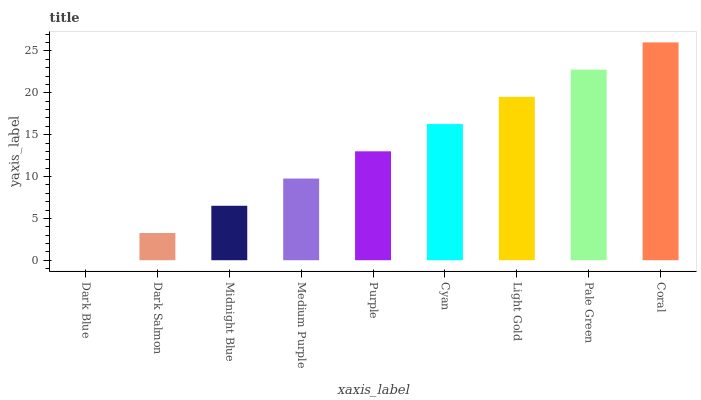Is Dark Blue the minimum?
Answer yes or no. Yes. Is Coral the maximum?
Answer yes or no. Yes. Is Dark Salmon the minimum?
Answer yes or no. No. Is Dark Salmon the maximum?
Answer yes or no. No. Is Dark Salmon greater than Dark Blue?
Answer yes or no. Yes. Is Dark Blue less than Dark Salmon?
Answer yes or no. Yes. Is Dark Blue greater than Dark Salmon?
Answer yes or no. No. Is Dark Salmon less than Dark Blue?
Answer yes or no. No. Is Purple the high median?
Answer yes or no. Yes. Is Purple the low median?
Answer yes or no. Yes. Is Dark Blue the high median?
Answer yes or no. No. Is Coral the low median?
Answer yes or no. No. 